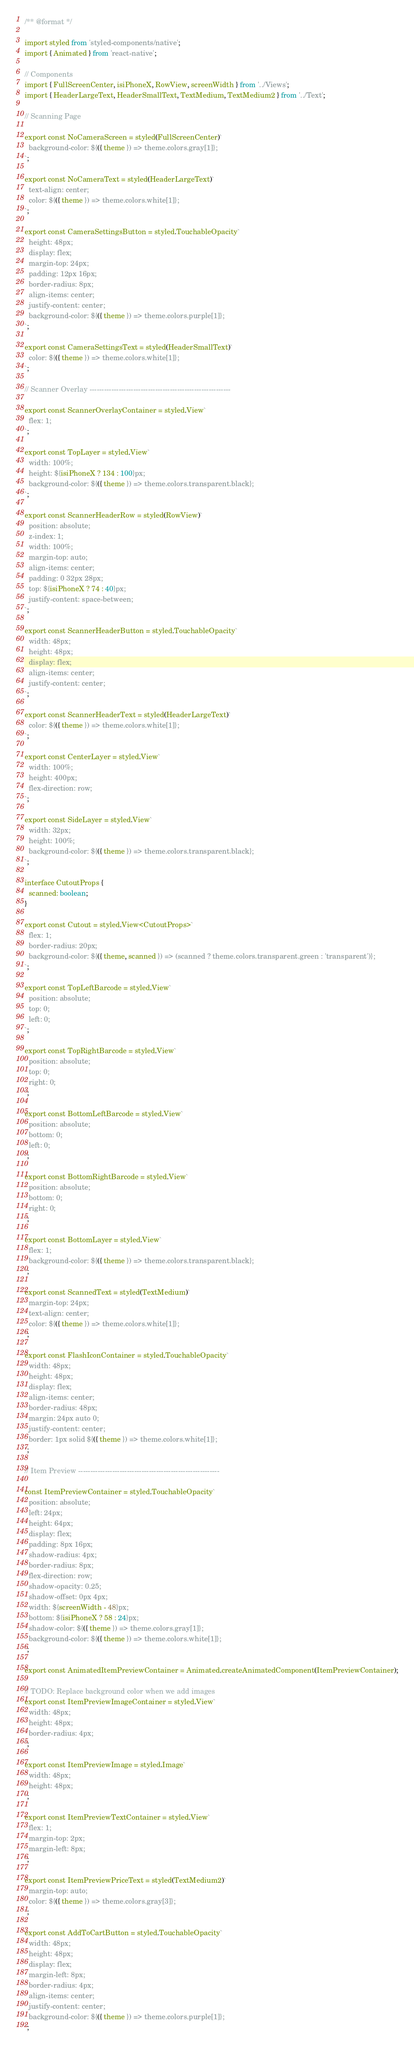Convert code to text. <code><loc_0><loc_0><loc_500><loc_500><_TypeScript_>/** @format */

import styled from 'styled-components/native';
import { Animated } from 'react-native';

// Components
import { FullScreenCenter, isiPhoneX, RowView, screenWidth } from '../Views';
import { HeaderLargeText, HeaderSmallText, TextMedium, TextMedium2 } from '../Text';

// Scanning Page

export const NoCameraScreen = styled(FullScreenCenter)`
  background-color: ${({ theme }) => theme.colors.gray[1]};
`;

export const NoCameraText = styled(HeaderLargeText)`
  text-align: center;
  color: ${({ theme }) => theme.colors.white[1]};
`;

export const CameraSettingsButton = styled.TouchableOpacity`
  height: 48px;
  display: flex;
  margin-top: 24px;
  padding: 12px 16px;
  border-radius: 8px;
  align-items: center;
  justify-content: center;
  background-color: ${({ theme }) => theme.colors.purple[1]};
`;

export const CameraSettingsText = styled(HeaderSmallText)`
  color: ${({ theme }) => theme.colors.white[1]};
`;

// Scanner Overlay ----------------------------------------------------------

export const ScannerOverlayContainer = styled.View`
  flex: 1;
`;

export const TopLayer = styled.View`
  width: 100%;
  height: ${isiPhoneX ? 134 : 100}px;
  background-color: ${({ theme }) => theme.colors.transparent.black};
`;

export const ScannerHeaderRow = styled(RowView)`
  position: absolute;
  z-index: 1;
  width: 100%;
  margin-top: auto;
  align-items: center;
  padding: 0 32px 28px;
  top: ${isiPhoneX ? 74 : 40}px;
  justify-content: space-between;
`;

export const ScannerHeaderButton = styled.TouchableOpacity`
  width: 48px;
  height: 48px;
  display: flex;
  align-items: center;
  justify-content: center;
`;

export const ScannerHeaderText = styled(HeaderLargeText)`
  color: ${({ theme }) => theme.colors.white[1]};
`;

export const CenterLayer = styled.View`
  width: 100%;
  height: 400px;
  flex-direction: row;
`;

export const SideLayer = styled.View`
  width: 32px;
  height: 100%;
  background-color: ${({ theme }) => theme.colors.transparent.black};
`;

interface CutoutProps {
  scanned: boolean;
}

export const Cutout = styled.View<CutoutProps>`
  flex: 1;
  border-radius: 20px;
  background-color: ${({ theme, scanned }) => (scanned ? theme.colors.transparent.green : 'transparent')};
`;

export const TopLeftBarcode = styled.View`
  position: absolute;
  top: 0;
  left: 0;
`;

export const TopRightBarcode = styled.View`
  position: absolute;
  top: 0;
  right: 0;
`;

export const BottomLeftBarcode = styled.View`
  position: absolute;
  bottom: 0;
  left: 0;
`;

export const BottomRightBarcode = styled.View`
  position: absolute;
  bottom: 0;
  right: 0;
`;

export const BottomLayer = styled.View`
  flex: 1;
  background-color: ${({ theme }) => theme.colors.transparent.black};
`;

export const ScannedText = styled(TextMedium)`
  margin-top: 24px;
  text-align: center;
  color: ${({ theme }) => theme.colors.white[1]};
`;

export const FlashIconContainer = styled.TouchableOpacity`
  width: 48px;
  height: 48px;
  display: flex;
  align-items: center;
  border-radius: 48px;
  margin: 24px auto 0;
  justify-content: center;
  border: 1px solid ${({ theme }) => theme.colors.white[1]};
`;

// Item Preview ----------------------------------------------------------

const ItemPreviewContainer = styled.TouchableOpacity`
  position: absolute;
  left: 24px;
  height: 64px;
  display: flex;
  padding: 8px 16px;
  shadow-radius: 4px;
  border-radius: 8px;
  flex-direction: row;
  shadow-opacity: 0.25;
  shadow-offset: 0px 4px;
  width: ${screenWidth - 48}px;
  bottom: ${isiPhoneX ? 58 : 24}px;
  shadow-color: ${({ theme }) => theme.colors.gray[1]};
  background-color: ${({ theme }) => theme.colors.white[1]};
`;

export const AnimatedItemPreviewContainer = Animated.createAnimatedComponent(ItemPreviewContainer);

// TODO: Replace background color when we add images
export const ItemPreviewImageContainer = styled.View`
  width: 48px;
  height: 48px;
  border-radius: 4px;
`;

export const ItemPreviewImage = styled.Image`
  width: 48px;
  height: 48px;
`;

export const ItemPreviewTextContainer = styled.View`
  flex: 1;
  margin-top: 2px;
  margin-left: 8px;
`;

export const ItemPreviewPriceText = styled(TextMedium2)`
  margin-top: auto;
  color: ${({ theme }) => theme.colors.gray[3]};
`;

export const AddToCartButton = styled.TouchableOpacity`
  width: 48px;
  height: 48px;
  display: flex;
  margin-left: 8px;
  border-radius: 4px;
  align-items: center;
  justify-content: center;
  background-color: ${({ theme }) => theme.colors.purple[1]};
`;
</code> 